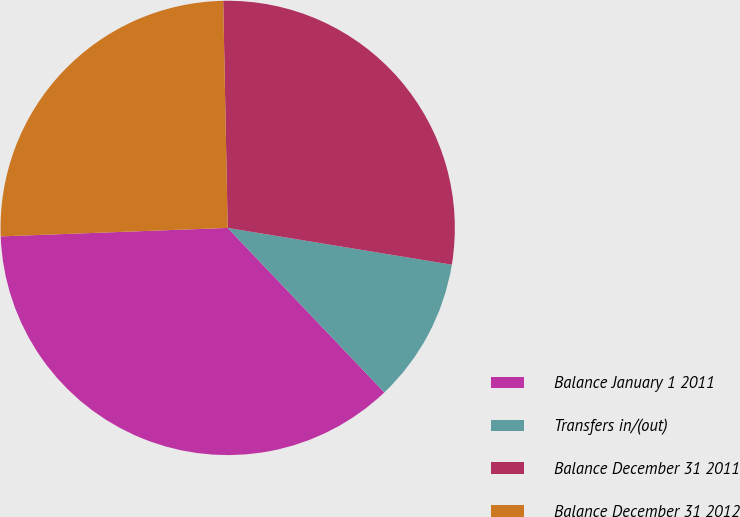<chart> <loc_0><loc_0><loc_500><loc_500><pie_chart><fcel>Balance January 1 2011<fcel>Transfers in/(out)<fcel>Balance December 31 2011<fcel>Balance December 31 2012<nl><fcel>36.52%<fcel>10.3%<fcel>27.9%<fcel>25.28%<nl></chart> 